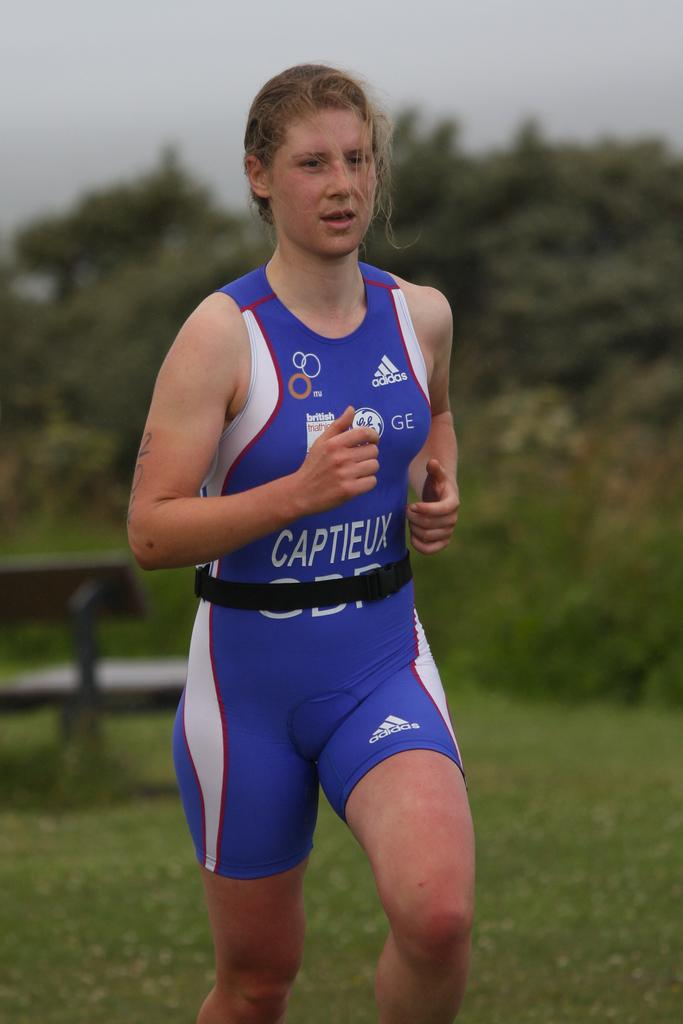<image>
Present a compact description of the photo's key features. A woman wearing a GE branded uniform is doing a cross-country run. 